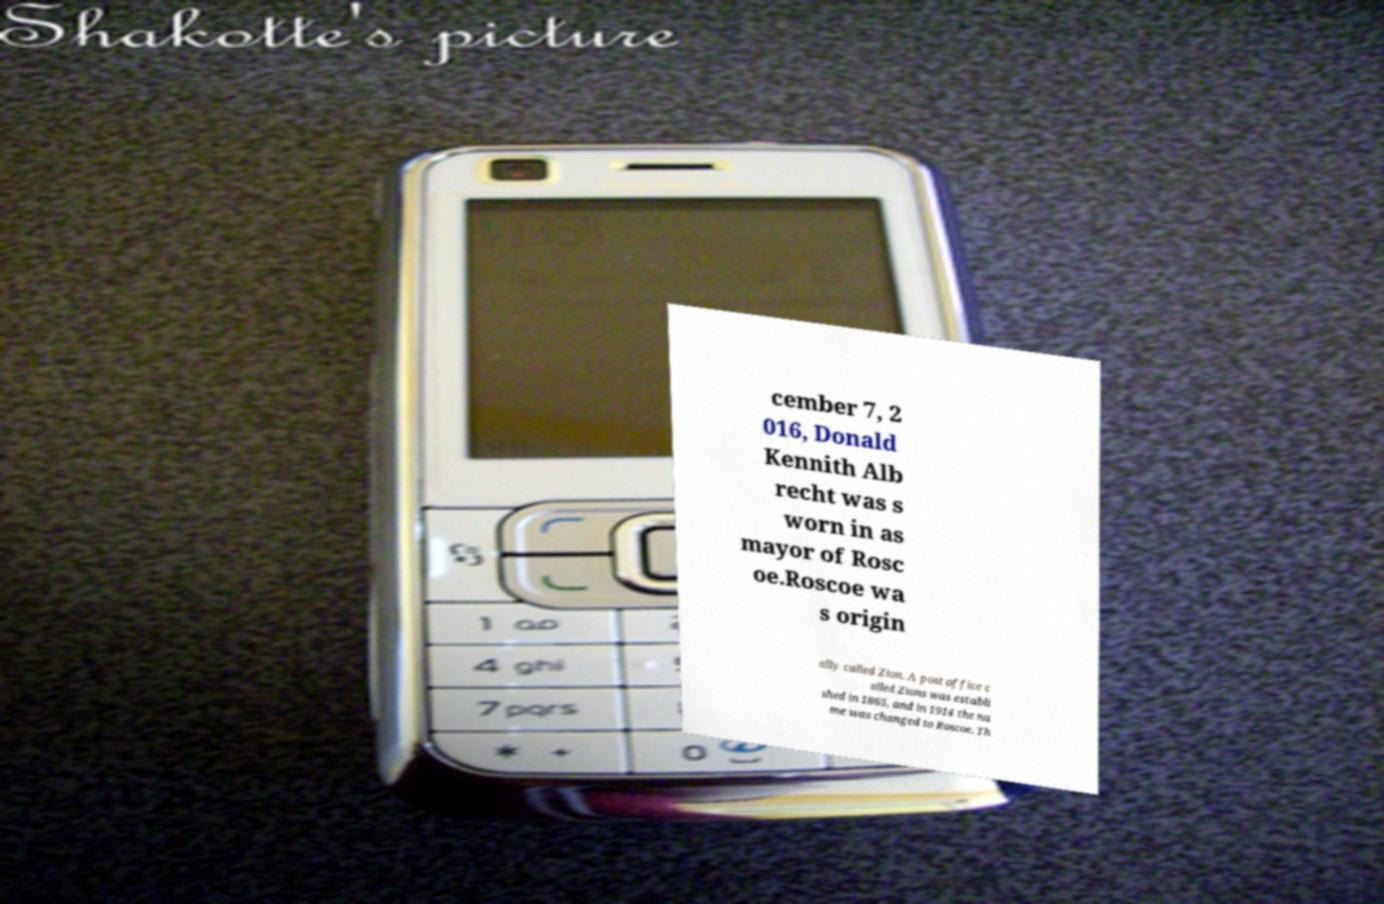I need the written content from this picture converted into text. Can you do that? cember 7, 2 016, Donald Kennith Alb recht was s worn in as mayor of Rosc oe.Roscoe wa s origin ally called Zion. A post office c alled Zions was establi shed in 1865, and in 1914 the na me was changed to Roscoe. Th 